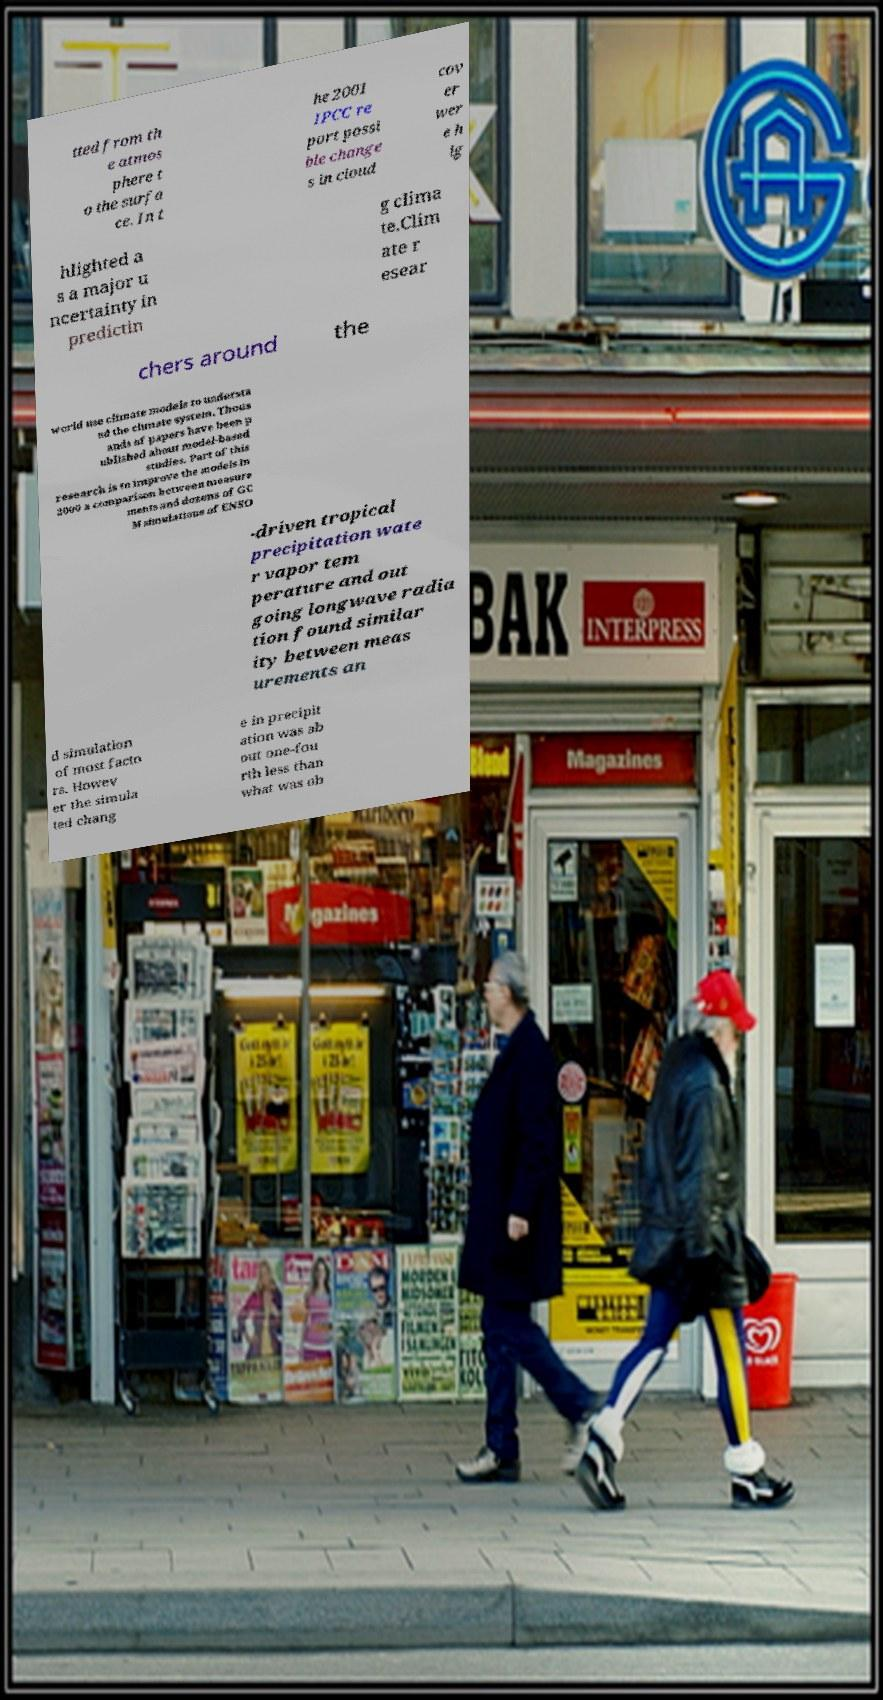Can you read and provide the text displayed in the image?This photo seems to have some interesting text. Can you extract and type it out for me? tted from th e atmos phere t o the surfa ce. In t he 2001 IPCC re port possi ble change s in cloud cov er wer e h ig hlighted a s a major u ncertainty in predictin g clima te.Clim ate r esear chers around the world use climate models to understa nd the climate system. Thous ands of papers have been p ublished about model-based studies. Part of this research is to improve the models.In 2000 a comparison between measure ments and dozens of GC M simulations of ENSO -driven tropical precipitation wate r vapor tem perature and out going longwave radia tion found similar ity between meas urements an d simulation of most facto rs. Howev er the simula ted chang e in precipit ation was ab out one-fou rth less than what was ob 